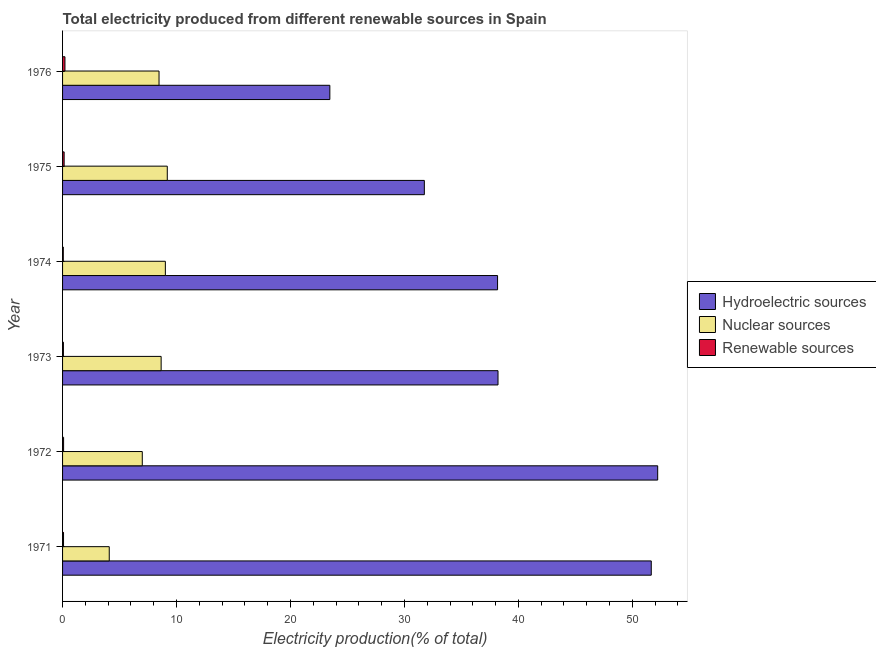How many groups of bars are there?
Your answer should be compact. 6. Are the number of bars per tick equal to the number of legend labels?
Provide a succinct answer. Yes. Are the number of bars on each tick of the Y-axis equal?
Your answer should be compact. Yes. In how many cases, is the number of bars for a given year not equal to the number of legend labels?
Make the answer very short. 0. What is the percentage of electricity produced by hydroelectric sources in 1976?
Your response must be concise. 23.45. Across all years, what is the maximum percentage of electricity produced by nuclear sources?
Your response must be concise. 9.19. Across all years, what is the minimum percentage of electricity produced by hydroelectric sources?
Make the answer very short. 23.45. In which year was the percentage of electricity produced by renewable sources maximum?
Provide a short and direct response. 1976. In which year was the percentage of electricity produced by hydroelectric sources minimum?
Your response must be concise. 1976. What is the total percentage of electricity produced by nuclear sources in the graph?
Your answer should be very brief. 46.42. What is the difference between the percentage of electricity produced by hydroelectric sources in 1974 and that in 1975?
Offer a terse response. 6.42. What is the difference between the percentage of electricity produced by renewable sources in 1976 and the percentage of electricity produced by nuclear sources in 1972?
Offer a terse response. -6.79. What is the average percentage of electricity produced by renewable sources per year?
Offer a very short reply. 0.11. In the year 1976, what is the difference between the percentage of electricity produced by renewable sources and percentage of electricity produced by hydroelectric sources?
Ensure brevity in your answer.  -23.25. What is the ratio of the percentage of electricity produced by nuclear sources in 1973 to that in 1975?
Ensure brevity in your answer.  0.94. Is the percentage of electricity produced by hydroelectric sources in 1974 less than that in 1976?
Your response must be concise. No. Is the difference between the percentage of electricity produced by nuclear sources in 1971 and 1972 greater than the difference between the percentage of electricity produced by hydroelectric sources in 1971 and 1972?
Give a very brief answer. No. What is the difference between the highest and the second highest percentage of electricity produced by renewable sources?
Make the answer very short. 0.07. What is the difference between the highest and the lowest percentage of electricity produced by hydroelectric sources?
Your answer should be compact. 28.77. In how many years, is the percentage of electricity produced by hydroelectric sources greater than the average percentage of electricity produced by hydroelectric sources taken over all years?
Your answer should be compact. 2. Is the sum of the percentage of electricity produced by nuclear sources in 1972 and 1975 greater than the maximum percentage of electricity produced by renewable sources across all years?
Keep it short and to the point. Yes. What does the 1st bar from the top in 1973 represents?
Your response must be concise. Renewable sources. What does the 1st bar from the bottom in 1971 represents?
Give a very brief answer. Hydroelectric sources. Is it the case that in every year, the sum of the percentage of electricity produced by hydroelectric sources and percentage of electricity produced by nuclear sources is greater than the percentage of electricity produced by renewable sources?
Ensure brevity in your answer.  Yes. How many years are there in the graph?
Make the answer very short. 6. Are the values on the major ticks of X-axis written in scientific E-notation?
Make the answer very short. No. Does the graph contain any zero values?
Offer a terse response. No. Does the graph contain grids?
Keep it short and to the point. No. How many legend labels are there?
Offer a terse response. 3. What is the title of the graph?
Your answer should be very brief. Total electricity produced from different renewable sources in Spain. Does "Self-employed" appear as one of the legend labels in the graph?
Offer a very short reply. No. What is the label or title of the X-axis?
Your answer should be very brief. Electricity production(% of total). What is the label or title of the Y-axis?
Provide a short and direct response. Year. What is the Electricity production(% of total) in Hydroelectric sources in 1971?
Provide a short and direct response. 51.66. What is the Electricity production(% of total) in Nuclear sources in 1971?
Your answer should be very brief. 4.1. What is the Electricity production(% of total) of Renewable sources in 1971?
Provide a succinct answer. 0.08. What is the Electricity production(% of total) in Hydroelectric sources in 1972?
Your response must be concise. 52.23. What is the Electricity production(% of total) of Nuclear sources in 1972?
Give a very brief answer. 7. What is the Electricity production(% of total) of Renewable sources in 1972?
Ensure brevity in your answer.  0.09. What is the Electricity production(% of total) in Hydroelectric sources in 1973?
Give a very brief answer. 38.21. What is the Electricity production(% of total) in Nuclear sources in 1973?
Your response must be concise. 8.65. What is the Electricity production(% of total) of Renewable sources in 1973?
Offer a very short reply. 0.07. What is the Electricity production(% of total) of Hydroelectric sources in 1974?
Keep it short and to the point. 38.17. What is the Electricity production(% of total) of Nuclear sources in 1974?
Provide a short and direct response. 9.02. What is the Electricity production(% of total) of Renewable sources in 1974?
Your response must be concise. 0.06. What is the Electricity production(% of total) in Hydroelectric sources in 1975?
Your answer should be compact. 31.75. What is the Electricity production(% of total) in Nuclear sources in 1975?
Offer a terse response. 9.19. What is the Electricity production(% of total) in Renewable sources in 1975?
Offer a very short reply. 0.14. What is the Electricity production(% of total) of Hydroelectric sources in 1976?
Provide a short and direct response. 23.45. What is the Electricity production(% of total) of Nuclear sources in 1976?
Provide a short and direct response. 8.47. What is the Electricity production(% of total) of Renewable sources in 1976?
Offer a very short reply. 0.21. Across all years, what is the maximum Electricity production(% of total) of Hydroelectric sources?
Ensure brevity in your answer.  52.23. Across all years, what is the maximum Electricity production(% of total) in Nuclear sources?
Keep it short and to the point. 9.19. Across all years, what is the maximum Electricity production(% of total) of Renewable sources?
Your answer should be compact. 0.21. Across all years, what is the minimum Electricity production(% of total) in Hydroelectric sources?
Make the answer very short. 23.45. Across all years, what is the minimum Electricity production(% of total) of Nuclear sources?
Ensure brevity in your answer.  4.1. Across all years, what is the minimum Electricity production(% of total) of Renewable sources?
Provide a short and direct response. 0.06. What is the total Electricity production(% of total) in Hydroelectric sources in the graph?
Your answer should be compact. 235.48. What is the total Electricity production(% of total) in Nuclear sources in the graph?
Provide a succinct answer. 46.42. What is the total Electricity production(% of total) of Renewable sources in the graph?
Provide a short and direct response. 0.66. What is the difference between the Electricity production(% of total) in Hydroelectric sources in 1971 and that in 1972?
Your answer should be very brief. -0.56. What is the difference between the Electricity production(% of total) of Nuclear sources in 1971 and that in 1972?
Offer a very short reply. -2.9. What is the difference between the Electricity production(% of total) in Renewable sources in 1971 and that in 1972?
Provide a short and direct response. -0.01. What is the difference between the Electricity production(% of total) of Hydroelectric sources in 1971 and that in 1973?
Make the answer very short. 13.45. What is the difference between the Electricity production(% of total) in Nuclear sources in 1971 and that in 1973?
Offer a terse response. -4.55. What is the difference between the Electricity production(% of total) in Renewable sources in 1971 and that in 1973?
Keep it short and to the point. 0.01. What is the difference between the Electricity production(% of total) of Hydroelectric sources in 1971 and that in 1974?
Your response must be concise. 13.49. What is the difference between the Electricity production(% of total) in Nuclear sources in 1971 and that in 1974?
Offer a very short reply. -4.92. What is the difference between the Electricity production(% of total) in Renewable sources in 1971 and that in 1974?
Give a very brief answer. 0.02. What is the difference between the Electricity production(% of total) in Hydroelectric sources in 1971 and that in 1975?
Provide a short and direct response. 19.91. What is the difference between the Electricity production(% of total) in Nuclear sources in 1971 and that in 1975?
Your response must be concise. -5.09. What is the difference between the Electricity production(% of total) in Renewable sources in 1971 and that in 1975?
Make the answer very short. -0.05. What is the difference between the Electricity production(% of total) of Hydroelectric sources in 1971 and that in 1976?
Provide a short and direct response. 28.21. What is the difference between the Electricity production(% of total) in Nuclear sources in 1971 and that in 1976?
Ensure brevity in your answer.  -4.37. What is the difference between the Electricity production(% of total) in Renewable sources in 1971 and that in 1976?
Your answer should be compact. -0.13. What is the difference between the Electricity production(% of total) of Hydroelectric sources in 1972 and that in 1973?
Your answer should be compact. 14.01. What is the difference between the Electricity production(% of total) in Nuclear sources in 1972 and that in 1973?
Your answer should be very brief. -1.66. What is the difference between the Electricity production(% of total) of Renewable sources in 1972 and that in 1973?
Provide a short and direct response. 0.02. What is the difference between the Electricity production(% of total) in Hydroelectric sources in 1972 and that in 1974?
Offer a terse response. 14.05. What is the difference between the Electricity production(% of total) in Nuclear sources in 1972 and that in 1974?
Give a very brief answer. -2.02. What is the difference between the Electricity production(% of total) in Renewable sources in 1972 and that in 1974?
Give a very brief answer. 0.03. What is the difference between the Electricity production(% of total) in Hydroelectric sources in 1972 and that in 1975?
Ensure brevity in your answer.  20.48. What is the difference between the Electricity production(% of total) in Nuclear sources in 1972 and that in 1975?
Ensure brevity in your answer.  -2.19. What is the difference between the Electricity production(% of total) in Renewable sources in 1972 and that in 1975?
Offer a very short reply. -0.05. What is the difference between the Electricity production(% of total) of Hydroelectric sources in 1972 and that in 1976?
Your answer should be very brief. 28.77. What is the difference between the Electricity production(% of total) in Nuclear sources in 1972 and that in 1976?
Your answer should be very brief. -1.47. What is the difference between the Electricity production(% of total) in Renewable sources in 1972 and that in 1976?
Your answer should be compact. -0.12. What is the difference between the Electricity production(% of total) in Hydroelectric sources in 1973 and that in 1974?
Keep it short and to the point. 0.04. What is the difference between the Electricity production(% of total) in Nuclear sources in 1973 and that in 1974?
Your answer should be compact. -0.37. What is the difference between the Electricity production(% of total) in Renewable sources in 1973 and that in 1974?
Your response must be concise. 0.01. What is the difference between the Electricity production(% of total) in Hydroelectric sources in 1973 and that in 1975?
Provide a short and direct response. 6.46. What is the difference between the Electricity production(% of total) of Nuclear sources in 1973 and that in 1975?
Your answer should be compact. -0.54. What is the difference between the Electricity production(% of total) in Renewable sources in 1973 and that in 1975?
Your response must be concise. -0.06. What is the difference between the Electricity production(% of total) of Hydroelectric sources in 1973 and that in 1976?
Provide a short and direct response. 14.76. What is the difference between the Electricity production(% of total) in Nuclear sources in 1973 and that in 1976?
Provide a succinct answer. 0.19. What is the difference between the Electricity production(% of total) in Renewable sources in 1973 and that in 1976?
Provide a short and direct response. -0.14. What is the difference between the Electricity production(% of total) in Hydroelectric sources in 1974 and that in 1975?
Your answer should be compact. 6.43. What is the difference between the Electricity production(% of total) in Nuclear sources in 1974 and that in 1975?
Your response must be concise. -0.17. What is the difference between the Electricity production(% of total) in Renewable sources in 1974 and that in 1975?
Make the answer very short. -0.07. What is the difference between the Electricity production(% of total) in Hydroelectric sources in 1974 and that in 1976?
Your answer should be compact. 14.72. What is the difference between the Electricity production(% of total) of Nuclear sources in 1974 and that in 1976?
Your response must be concise. 0.55. What is the difference between the Electricity production(% of total) in Renewable sources in 1974 and that in 1976?
Offer a terse response. -0.15. What is the difference between the Electricity production(% of total) of Hydroelectric sources in 1975 and that in 1976?
Your response must be concise. 8.29. What is the difference between the Electricity production(% of total) of Nuclear sources in 1975 and that in 1976?
Provide a succinct answer. 0.72. What is the difference between the Electricity production(% of total) in Renewable sources in 1975 and that in 1976?
Make the answer very short. -0.07. What is the difference between the Electricity production(% of total) in Hydroelectric sources in 1971 and the Electricity production(% of total) in Nuclear sources in 1972?
Your response must be concise. 44.67. What is the difference between the Electricity production(% of total) of Hydroelectric sources in 1971 and the Electricity production(% of total) of Renewable sources in 1972?
Give a very brief answer. 51.57. What is the difference between the Electricity production(% of total) of Nuclear sources in 1971 and the Electricity production(% of total) of Renewable sources in 1972?
Provide a short and direct response. 4.01. What is the difference between the Electricity production(% of total) in Hydroelectric sources in 1971 and the Electricity production(% of total) in Nuclear sources in 1973?
Provide a succinct answer. 43.01. What is the difference between the Electricity production(% of total) of Hydroelectric sources in 1971 and the Electricity production(% of total) of Renewable sources in 1973?
Give a very brief answer. 51.59. What is the difference between the Electricity production(% of total) of Nuclear sources in 1971 and the Electricity production(% of total) of Renewable sources in 1973?
Offer a very short reply. 4.02. What is the difference between the Electricity production(% of total) of Hydroelectric sources in 1971 and the Electricity production(% of total) of Nuclear sources in 1974?
Offer a very short reply. 42.64. What is the difference between the Electricity production(% of total) of Hydroelectric sources in 1971 and the Electricity production(% of total) of Renewable sources in 1974?
Provide a short and direct response. 51.6. What is the difference between the Electricity production(% of total) in Nuclear sources in 1971 and the Electricity production(% of total) in Renewable sources in 1974?
Ensure brevity in your answer.  4.03. What is the difference between the Electricity production(% of total) in Hydroelectric sources in 1971 and the Electricity production(% of total) in Nuclear sources in 1975?
Give a very brief answer. 42.47. What is the difference between the Electricity production(% of total) of Hydroelectric sources in 1971 and the Electricity production(% of total) of Renewable sources in 1975?
Offer a very short reply. 51.52. What is the difference between the Electricity production(% of total) of Nuclear sources in 1971 and the Electricity production(% of total) of Renewable sources in 1975?
Provide a short and direct response. 3.96. What is the difference between the Electricity production(% of total) of Hydroelectric sources in 1971 and the Electricity production(% of total) of Nuclear sources in 1976?
Your response must be concise. 43.2. What is the difference between the Electricity production(% of total) of Hydroelectric sources in 1971 and the Electricity production(% of total) of Renewable sources in 1976?
Ensure brevity in your answer.  51.45. What is the difference between the Electricity production(% of total) in Nuclear sources in 1971 and the Electricity production(% of total) in Renewable sources in 1976?
Give a very brief answer. 3.89. What is the difference between the Electricity production(% of total) in Hydroelectric sources in 1972 and the Electricity production(% of total) in Nuclear sources in 1973?
Ensure brevity in your answer.  43.58. What is the difference between the Electricity production(% of total) in Hydroelectric sources in 1972 and the Electricity production(% of total) in Renewable sources in 1973?
Keep it short and to the point. 52.15. What is the difference between the Electricity production(% of total) in Nuclear sources in 1972 and the Electricity production(% of total) in Renewable sources in 1973?
Give a very brief answer. 6.92. What is the difference between the Electricity production(% of total) in Hydroelectric sources in 1972 and the Electricity production(% of total) in Nuclear sources in 1974?
Provide a succinct answer. 43.21. What is the difference between the Electricity production(% of total) in Hydroelectric sources in 1972 and the Electricity production(% of total) in Renewable sources in 1974?
Your response must be concise. 52.16. What is the difference between the Electricity production(% of total) in Nuclear sources in 1972 and the Electricity production(% of total) in Renewable sources in 1974?
Give a very brief answer. 6.93. What is the difference between the Electricity production(% of total) of Hydroelectric sources in 1972 and the Electricity production(% of total) of Nuclear sources in 1975?
Your answer should be compact. 43.04. What is the difference between the Electricity production(% of total) in Hydroelectric sources in 1972 and the Electricity production(% of total) in Renewable sources in 1975?
Offer a terse response. 52.09. What is the difference between the Electricity production(% of total) in Nuclear sources in 1972 and the Electricity production(% of total) in Renewable sources in 1975?
Ensure brevity in your answer.  6.86. What is the difference between the Electricity production(% of total) in Hydroelectric sources in 1972 and the Electricity production(% of total) in Nuclear sources in 1976?
Offer a terse response. 43.76. What is the difference between the Electricity production(% of total) in Hydroelectric sources in 1972 and the Electricity production(% of total) in Renewable sources in 1976?
Keep it short and to the point. 52.02. What is the difference between the Electricity production(% of total) of Nuclear sources in 1972 and the Electricity production(% of total) of Renewable sources in 1976?
Offer a terse response. 6.79. What is the difference between the Electricity production(% of total) in Hydroelectric sources in 1973 and the Electricity production(% of total) in Nuclear sources in 1974?
Your answer should be compact. 29.19. What is the difference between the Electricity production(% of total) in Hydroelectric sources in 1973 and the Electricity production(% of total) in Renewable sources in 1974?
Your answer should be compact. 38.15. What is the difference between the Electricity production(% of total) of Nuclear sources in 1973 and the Electricity production(% of total) of Renewable sources in 1974?
Your answer should be compact. 8.59. What is the difference between the Electricity production(% of total) in Hydroelectric sources in 1973 and the Electricity production(% of total) in Nuclear sources in 1975?
Your answer should be compact. 29.02. What is the difference between the Electricity production(% of total) in Hydroelectric sources in 1973 and the Electricity production(% of total) in Renewable sources in 1975?
Offer a very short reply. 38.08. What is the difference between the Electricity production(% of total) in Nuclear sources in 1973 and the Electricity production(% of total) in Renewable sources in 1975?
Your answer should be very brief. 8.51. What is the difference between the Electricity production(% of total) in Hydroelectric sources in 1973 and the Electricity production(% of total) in Nuclear sources in 1976?
Your response must be concise. 29.75. What is the difference between the Electricity production(% of total) of Hydroelectric sources in 1973 and the Electricity production(% of total) of Renewable sources in 1976?
Give a very brief answer. 38. What is the difference between the Electricity production(% of total) in Nuclear sources in 1973 and the Electricity production(% of total) in Renewable sources in 1976?
Provide a short and direct response. 8.44. What is the difference between the Electricity production(% of total) of Hydroelectric sources in 1974 and the Electricity production(% of total) of Nuclear sources in 1975?
Offer a very short reply. 28.98. What is the difference between the Electricity production(% of total) in Hydroelectric sources in 1974 and the Electricity production(% of total) in Renewable sources in 1975?
Offer a terse response. 38.04. What is the difference between the Electricity production(% of total) of Nuclear sources in 1974 and the Electricity production(% of total) of Renewable sources in 1975?
Offer a terse response. 8.88. What is the difference between the Electricity production(% of total) of Hydroelectric sources in 1974 and the Electricity production(% of total) of Nuclear sources in 1976?
Offer a terse response. 29.71. What is the difference between the Electricity production(% of total) of Hydroelectric sources in 1974 and the Electricity production(% of total) of Renewable sources in 1976?
Make the answer very short. 37.96. What is the difference between the Electricity production(% of total) of Nuclear sources in 1974 and the Electricity production(% of total) of Renewable sources in 1976?
Your response must be concise. 8.81. What is the difference between the Electricity production(% of total) of Hydroelectric sources in 1975 and the Electricity production(% of total) of Nuclear sources in 1976?
Your answer should be very brief. 23.28. What is the difference between the Electricity production(% of total) of Hydroelectric sources in 1975 and the Electricity production(% of total) of Renewable sources in 1976?
Provide a short and direct response. 31.54. What is the difference between the Electricity production(% of total) of Nuclear sources in 1975 and the Electricity production(% of total) of Renewable sources in 1976?
Offer a terse response. 8.98. What is the average Electricity production(% of total) of Hydroelectric sources per year?
Provide a short and direct response. 39.25. What is the average Electricity production(% of total) in Nuclear sources per year?
Offer a terse response. 7.74. What is the average Electricity production(% of total) of Renewable sources per year?
Your response must be concise. 0.11. In the year 1971, what is the difference between the Electricity production(% of total) of Hydroelectric sources and Electricity production(% of total) of Nuclear sources?
Give a very brief answer. 47.57. In the year 1971, what is the difference between the Electricity production(% of total) in Hydroelectric sources and Electricity production(% of total) in Renewable sources?
Make the answer very short. 51.58. In the year 1971, what is the difference between the Electricity production(% of total) in Nuclear sources and Electricity production(% of total) in Renewable sources?
Give a very brief answer. 4.01. In the year 1972, what is the difference between the Electricity production(% of total) in Hydroelectric sources and Electricity production(% of total) in Nuclear sources?
Make the answer very short. 45.23. In the year 1972, what is the difference between the Electricity production(% of total) of Hydroelectric sources and Electricity production(% of total) of Renewable sources?
Offer a very short reply. 52.14. In the year 1972, what is the difference between the Electricity production(% of total) of Nuclear sources and Electricity production(% of total) of Renewable sources?
Offer a terse response. 6.91. In the year 1973, what is the difference between the Electricity production(% of total) of Hydroelectric sources and Electricity production(% of total) of Nuclear sources?
Provide a succinct answer. 29.56. In the year 1973, what is the difference between the Electricity production(% of total) in Hydroelectric sources and Electricity production(% of total) in Renewable sources?
Keep it short and to the point. 38.14. In the year 1973, what is the difference between the Electricity production(% of total) of Nuclear sources and Electricity production(% of total) of Renewable sources?
Make the answer very short. 8.58. In the year 1974, what is the difference between the Electricity production(% of total) in Hydroelectric sources and Electricity production(% of total) in Nuclear sources?
Your response must be concise. 29.15. In the year 1974, what is the difference between the Electricity production(% of total) in Hydroelectric sources and Electricity production(% of total) in Renewable sources?
Offer a terse response. 38.11. In the year 1974, what is the difference between the Electricity production(% of total) in Nuclear sources and Electricity production(% of total) in Renewable sources?
Your answer should be very brief. 8.96. In the year 1975, what is the difference between the Electricity production(% of total) of Hydroelectric sources and Electricity production(% of total) of Nuclear sources?
Your answer should be compact. 22.56. In the year 1975, what is the difference between the Electricity production(% of total) of Hydroelectric sources and Electricity production(% of total) of Renewable sources?
Your answer should be very brief. 31.61. In the year 1975, what is the difference between the Electricity production(% of total) in Nuclear sources and Electricity production(% of total) in Renewable sources?
Offer a terse response. 9.05. In the year 1976, what is the difference between the Electricity production(% of total) of Hydroelectric sources and Electricity production(% of total) of Nuclear sources?
Make the answer very short. 14.99. In the year 1976, what is the difference between the Electricity production(% of total) of Hydroelectric sources and Electricity production(% of total) of Renewable sources?
Give a very brief answer. 23.25. In the year 1976, what is the difference between the Electricity production(% of total) in Nuclear sources and Electricity production(% of total) in Renewable sources?
Provide a succinct answer. 8.26. What is the ratio of the Electricity production(% of total) of Nuclear sources in 1971 to that in 1972?
Provide a short and direct response. 0.59. What is the ratio of the Electricity production(% of total) in Renewable sources in 1971 to that in 1972?
Provide a succinct answer. 0.94. What is the ratio of the Electricity production(% of total) of Hydroelectric sources in 1971 to that in 1973?
Keep it short and to the point. 1.35. What is the ratio of the Electricity production(% of total) in Nuclear sources in 1971 to that in 1973?
Make the answer very short. 0.47. What is the ratio of the Electricity production(% of total) in Renewable sources in 1971 to that in 1973?
Your response must be concise. 1.14. What is the ratio of the Electricity production(% of total) in Hydroelectric sources in 1971 to that in 1974?
Your response must be concise. 1.35. What is the ratio of the Electricity production(% of total) in Nuclear sources in 1971 to that in 1974?
Your answer should be very brief. 0.45. What is the ratio of the Electricity production(% of total) of Renewable sources in 1971 to that in 1974?
Provide a short and direct response. 1.33. What is the ratio of the Electricity production(% of total) of Hydroelectric sources in 1971 to that in 1975?
Keep it short and to the point. 1.63. What is the ratio of the Electricity production(% of total) in Nuclear sources in 1971 to that in 1975?
Your answer should be very brief. 0.45. What is the ratio of the Electricity production(% of total) in Renewable sources in 1971 to that in 1975?
Give a very brief answer. 0.61. What is the ratio of the Electricity production(% of total) of Hydroelectric sources in 1971 to that in 1976?
Your answer should be very brief. 2.2. What is the ratio of the Electricity production(% of total) of Nuclear sources in 1971 to that in 1976?
Give a very brief answer. 0.48. What is the ratio of the Electricity production(% of total) in Renewable sources in 1971 to that in 1976?
Your answer should be compact. 0.4. What is the ratio of the Electricity production(% of total) in Hydroelectric sources in 1972 to that in 1973?
Make the answer very short. 1.37. What is the ratio of the Electricity production(% of total) in Nuclear sources in 1972 to that in 1973?
Offer a terse response. 0.81. What is the ratio of the Electricity production(% of total) in Renewable sources in 1972 to that in 1973?
Offer a terse response. 1.21. What is the ratio of the Electricity production(% of total) of Hydroelectric sources in 1972 to that in 1974?
Give a very brief answer. 1.37. What is the ratio of the Electricity production(% of total) in Nuclear sources in 1972 to that in 1974?
Your response must be concise. 0.78. What is the ratio of the Electricity production(% of total) of Renewable sources in 1972 to that in 1974?
Offer a very short reply. 1.41. What is the ratio of the Electricity production(% of total) of Hydroelectric sources in 1972 to that in 1975?
Give a very brief answer. 1.65. What is the ratio of the Electricity production(% of total) in Nuclear sources in 1972 to that in 1975?
Provide a short and direct response. 0.76. What is the ratio of the Electricity production(% of total) in Renewable sources in 1972 to that in 1975?
Provide a short and direct response. 0.65. What is the ratio of the Electricity production(% of total) of Hydroelectric sources in 1972 to that in 1976?
Make the answer very short. 2.23. What is the ratio of the Electricity production(% of total) of Nuclear sources in 1972 to that in 1976?
Provide a succinct answer. 0.83. What is the ratio of the Electricity production(% of total) in Renewable sources in 1972 to that in 1976?
Give a very brief answer. 0.43. What is the ratio of the Electricity production(% of total) in Renewable sources in 1973 to that in 1974?
Your answer should be compact. 1.16. What is the ratio of the Electricity production(% of total) in Hydroelectric sources in 1973 to that in 1975?
Make the answer very short. 1.2. What is the ratio of the Electricity production(% of total) in Nuclear sources in 1973 to that in 1975?
Offer a terse response. 0.94. What is the ratio of the Electricity production(% of total) in Renewable sources in 1973 to that in 1975?
Offer a very short reply. 0.54. What is the ratio of the Electricity production(% of total) of Hydroelectric sources in 1973 to that in 1976?
Your answer should be very brief. 1.63. What is the ratio of the Electricity production(% of total) in Nuclear sources in 1973 to that in 1976?
Your response must be concise. 1.02. What is the ratio of the Electricity production(% of total) of Renewable sources in 1973 to that in 1976?
Provide a succinct answer. 0.35. What is the ratio of the Electricity production(% of total) in Hydroelectric sources in 1974 to that in 1975?
Your response must be concise. 1.2. What is the ratio of the Electricity production(% of total) of Nuclear sources in 1974 to that in 1975?
Your answer should be compact. 0.98. What is the ratio of the Electricity production(% of total) of Renewable sources in 1974 to that in 1975?
Ensure brevity in your answer.  0.46. What is the ratio of the Electricity production(% of total) in Hydroelectric sources in 1974 to that in 1976?
Offer a terse response. 1.63. What is the ratio of the Electricity production(% of total) in Nuclear sources in 1974 to that in 1976?
Keep it short and to the point. 1.07. What is the ratio of the Electricity production(% of total) in Renewable sources in 1974 to that in 1976?
Your response must be concise. 0.3. What is the ratio of the Electricity production(% of total) of Hydroelectric sources in 1975 to that in 1976?
Your answer should be very brief. 1.35. What is the ratio of the Electricity production(% of total) in Nuclear sources in 1975 to that in 1976?
Ensure brevity in your answer.  1.09. What is the ratio of the Electricity production(% of total) of Renewable sources in 1975 to that in 1976?
Ensure brevity in your answer.  0.66. What is the difference between the highest and the second highest Electricity production(% of total) in Hydroelectric sources?
Make the answer very short. 0.56. What is the difference between the highest and the second highest Electricity production(% of total) of Nuclear sources?
Offer a very short reply. 0.17. What is the difference between the highest and the second highest Electricity production(% of total) in Renewable sources?
Ensure brevity in your answer.  0.07. What is the difference between the highest and the lowest Electricity production(% of total) in Hydroelectric sources?
Your answer should be very brief. 28.77. What is the difference between the highest and the lowest Electricity production(% of total) of Nuclear sources?
Your response must be concise. 5.09. What is the difference between the highest and the lowest Electricity production(% of total) in Renewable sources?
Keep it short and to the point. 0.15. 